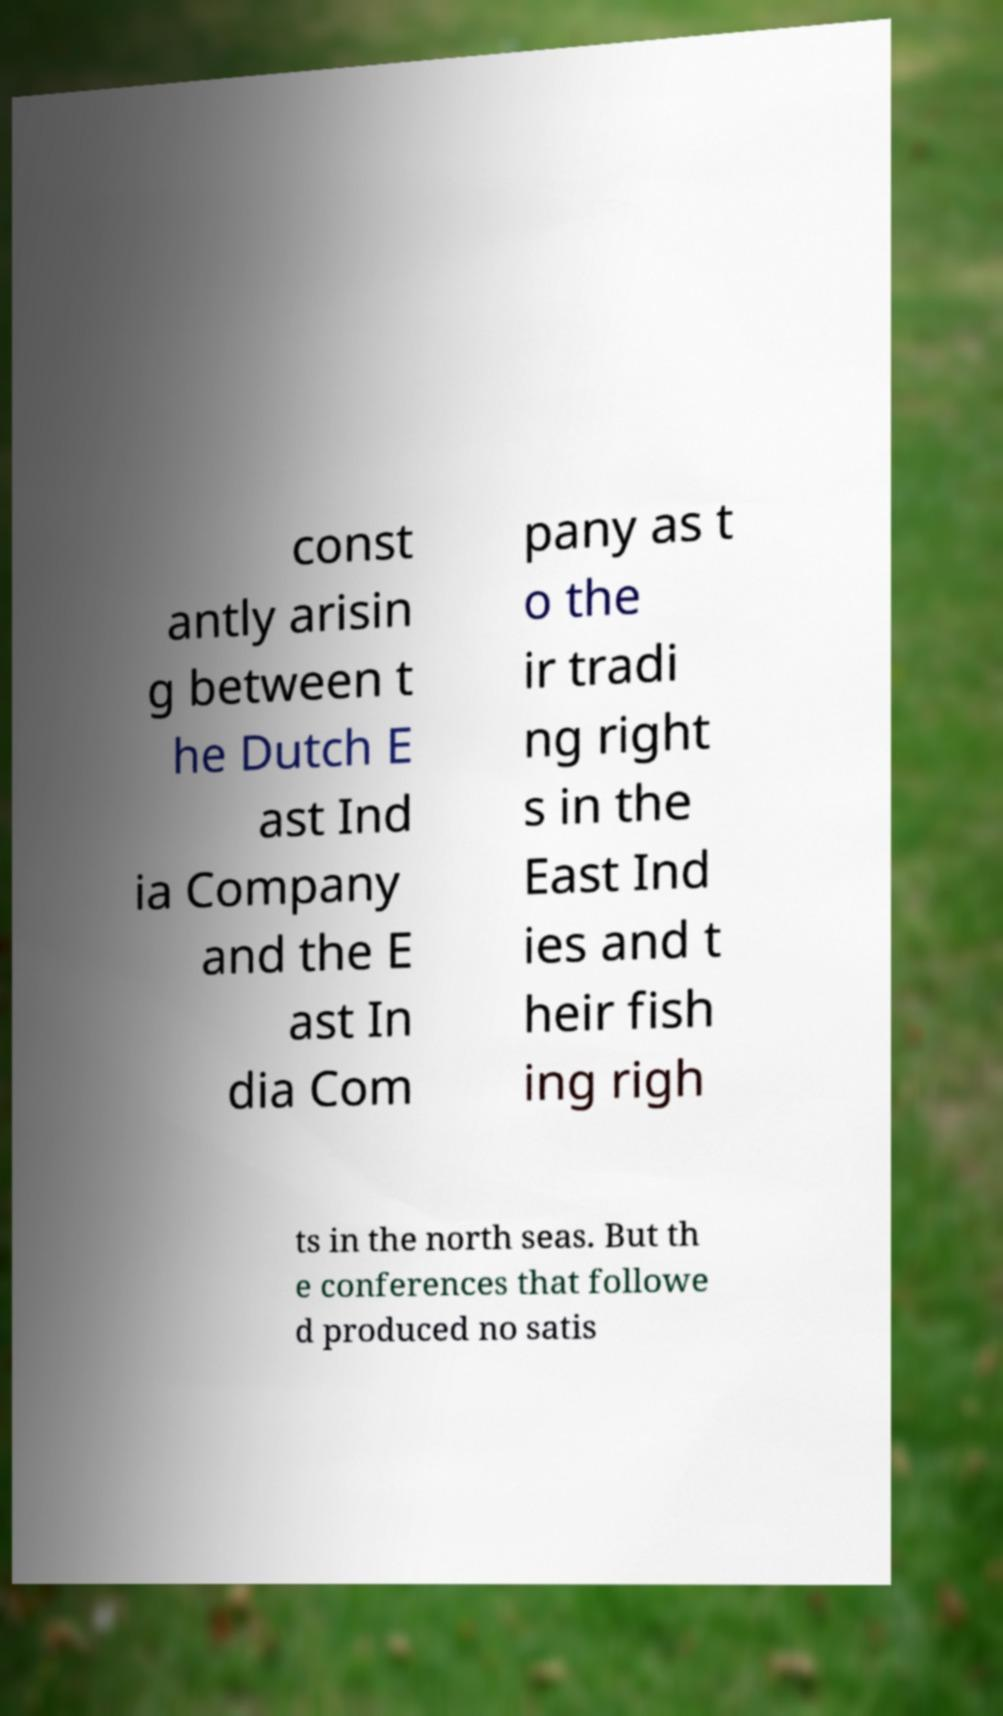What messages or text are displayed in this image? I need them in a readable, typed format. const antly arisin g between t he Dutch E ast Ind ia Company and the E ast In dia Com pany as t o the ir tradi ng right s in the East Ind ies and t heir fish ing righ ts in the north seas. But th e conferences that followe d produced no satis 